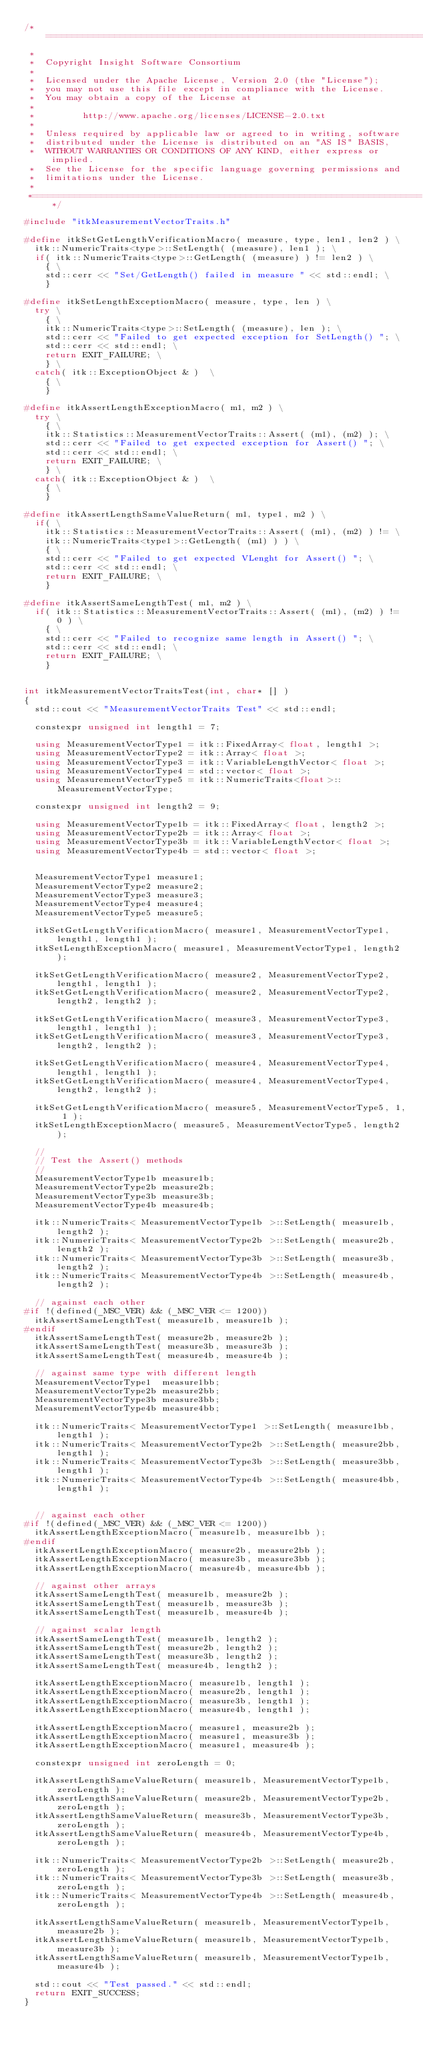Convert code to text. <code><loc_0><loc_0><loc_500><loc_500><_C++_>/*=========================================================================
 *
 *  Copyright Insight Software Consortium
 *
 *  Licensed under the Apache License, Version 2.0 (the "License");
 *  you may not use this file except in compliance with the License.
 *  You may obtain a copy of the License at
 *
 *         http://www.apache.org/licenses/LICENSE-2.0.txt
 *
 *  Unless required by applicable law or agreed to in writing, software
 *  distributed under the License is distributed on an "AS IS" BASIS,
 *  WITHOUT WARRANTIES OR CONDITIONS OF ANY KIND, either express or implied.
 *  See the License for the specific language governing permissions and
 *  limitations under the License.
 *
 *=========================================================================*/

#include "itkMeasurementVectorTraits.h"

#define itkSetGetLengthVerificationMacro( measure, type, len1, len2 ) \
  itk::NumericTraits<type>::SetLength( (measure), len1 ); \
  if( itk::NumericTraits<type>::GetLength( (measure) ) != len2 ) \
    { \
    std::cerr << "Set/GetLength() failed in measure " << std::endl; \
    }

#define itkSetLengthExceptionMacro( measure, type, len ) \
  try \
    { \
    itk::NumericTraits<type>::SetLength( (measure), len ); \
    std::cerr << "Failed to get expected exception for SetLength() "; \
    std::cerr << std::endl; \
    return EXIT_FAILURE; \
    } \
  catch( itk::ExceptionObject & )  \
    { \
    }

#define itkAssertLengthExceptionMacro( m1, m2 ) \
  try \
    { \
    itk::Statistics::MeasurementVectorTraits::Assert( (m1), (m2) ); \
    std::cerr << "Failed to get expected exception for Assert() "; \
    std::cerr << std::endl; \
    return EXIT_FAILURE; \
    } \
  catch( itk::ExceptionObject & )  \
    { \
    }

#define itkAssertLengthSameValueReturn( m1, type1, m2 ) \
  if( \
    itk::Statistics::MeasurementVectorTraits::Assert( (m1), (m2) ) != \
    itk::NumericTraits<type1>::GetLength( (m1) ) ) \
    { \
    std::cerr << "Failed to get expected VLenght for Assert() "; \
    std::cerr << std::endl; \
    return EXIT_FAILURE; \
    }

#define itkAssertSameLengthTest( m1, m2 ) \
  if( itk::Statistics::MeasurementVectorTraits::Assert( (m1), (m2) ) != 0 ) \
    { \
    std::cerr << "Failed to recognize same length in Assert() "; \
    std::cerr << std::endl; \
    return EXIT_FAILURE; \
    }


int itkMeasurementVectorTraitsTest(int, char* [] )
{
  std::cout << "MeasurementVectorTraits Test" << std::endl;

  constexpr unsigned int length1 = 7;

  using MeasurementVectorType1 = itk::FixedArray< float, length1 >;
  using MeasurementVectorType2 = itk::Array< float >;
  using MeasurementVectorType3 = itk::VariableLengthVector< float >;
  using MeasurementVectorType4 = std::vector< float >;
  using MeasurementVectorType5 = itk::NumericTraits<float>::MeasurementVectorType;

  constexpr unsigned int length2 = 9;

  using MeasurementVectorType1b = itk::FixedArray< float, length2 >;
  using MeasurementVectorType2b = itk::Array< float >;
  using MeasurementVectorType3b = itk::VariableLengthVector< float >;
  using MeasurementVectorType4b = std::vector< float >;


  MeasurementVectorType1 measure1;
  MeasurementVectorType2 measure2;
  MeasurementVectorType3 measure3;
  MeasurementVectorType4 measure4;
  MeasurementVectorType5 measure5;

  itkSetGetLengthVerificationMacro( measure1, MeasurementVectorType1, length1, length1 );
  itkSetLengthExceptionMacro( measure1, MeasurementVectorType1, length2 );

  itkSetGetLengthVerificationMacro( measure2, MeasurementVectorType2, length1, length1 );
  itkSetGetLengthVerificationMacro( measure2, MeasurementVectorType2, length2, length2 );

  itkSetGetLengthVerificationMacro( measure3, MeasurementVectorType3, length1, length1 );
  itkSetGetLengthVerificationMacro( measure3, MeasurementVectorType3, length2, length2 );

  itkSetGetLengthVerificationMacro( measure4, MeasurementVectorType4, length1, length1 );
  itkSetGetLengthVerificationMacro( measure4, MeasurementVectorType4, length2, length2 );

  itkSetGetLengthVerificationMacro( measure5, MeasurementVectorType5, 1, 1 );
  itkSetLengthExceptionMacro( measure5, MeasurementVectorType5, length2 );

  //
  // Test the Assert() methods
  //
  MeasurementVectorType1b measure1b;
  MeasurementVectorType2b measure2b;
  MeasurementVectorType3b measure3b;
  MeasurementVectorType4b measure4b;

  itk::NumericTraits< MeasurementVectorType1b >::SetLength( measure1b, length2 );
  itk::NumericTraits< MeasurementVectorType2b >::SetLength( measure2b, length2 );
  itk::NumericTraits< MeasurementVectorType3b >::SetLength( measure3b, length2 );
  itk::NumericTraits< MeasurementVectorType4b >::SetLength( measure4b, length2 );

  // against each other
#if !(defined(_MSC_VER) && (_MSC_VER <= 1200))
  itkAssertSameLengthTest( measure1b, measure1b );
#endif
  itkAssertSameLengthTest( measure2b, measure2b );
  itkAssertSameLengthTest( measure3b, measure3b );
  itkAssertSameLengthTest( measure4b, measure4b );

  // against same type with different length
  MeasurementVectorType1  measure1bb;
  MeasurementVectorType2b measure2bb;
  MeasurementVectorType3b measure3bb;
  MeasurementVectorType4b measure4bb;

  itk::NumericTraits< MeasurementVectorType1 >::SetLength( measure1bb, length1 );
  itk::NumericTraits< MeasurementVectorType2b >::SetLength( measure2bb, length1 );
  itk::NumericTraits< MeasurementVectorType3b >::SetLength( measure3bb, length1 );
  itk::NumericTraits< MeasurementVectorType4b >::SetLength( measure4bb, length1 );


  // against each other
#if !(defined(_MSC_VER) && (_MSC_VER <= 1200))
  itkAssertLengthExceptionMacro( measure1b, measure1bb );
#endif
  itkAssertLengthExceptionMacro( measure2b, measure2bb );
  itkAssertLengthExceptionMacro( measure3b, measure3bb );
  itkAssertLengthExceptionMacro( measure4b, measure4bb );

  // against other arrays
  itkAssertSameLengthTest( measure1b, measure2b );
  itkAssertSameLengthTest( measure1b, measure3b );
  itkAssertSameLengthTest( measure1b, measure4b );

  // against scalar length
  itkAssertSameLengthTest( measure1b, length2 );
  itkAssertSameLengthTest( measure2b, length2 );
  itkAssertSameLengthTest( measure3b, length2 );
  itkAssertSameLengthTest( measure4b, length2 );

  itkAssertLengthExceptionMacro( measure1b, length1 );
  itkAssertLengthExceptionMacro( measure2b, length1 );
  itkAssertLengthExceptionMacro( measure3b, length1 );
  itkAssertLengthExceptionMacro( measure4b, length1 );

  itkAssertLengthExceptionMacro( measure1, measure2b );
  itkAssertLengthExceptionMacro( measure1, measure3b );
  itkAssertLengthExceptionMacro( measure1, measure4b );

  constexpr unsigned int zeroLength = 0;

  itkAssertLengthSameValueReturn( measure1b, MeasurementVectorType1b, zeroLength );
  itkAssertLengthSameValueReturn( measure2b, MeasurementVectorType2b, zeroLength );
  itkAssertLengthSameValueReturn( measure3b, MeasurementVectorType3b, zeroLength );
  itkAssertLengthSameValueReturn( measure4b, MeasurementVectorType4b, zeroLength );

  itk::NumericTraits< MeasurementVectorType2b >::SetLength( measure2b, zeroLength );
  itk::NumericTraits< MeasurementVectorType3b >::SetLength( measure3b, zeroLength );
  itk::NumericTraits< MeasurementVectorType4b >::SetLength( measure4b, zeroLength );

  itkAssertLengthSameValueReturn( measure1b, MeasurementVectorType1b, measure2b );
  itkAssertLengthSameValueReturn( measure1b, MeasurementVectorType1b, measure3b );
  itkAssertLengthSameValueReturn( measure1b, MeasurementVectorType1b, measure4b );

  std::cout << "Test passed." << std::endl;
  return EXIT_SUCCESS;
}
</code> 